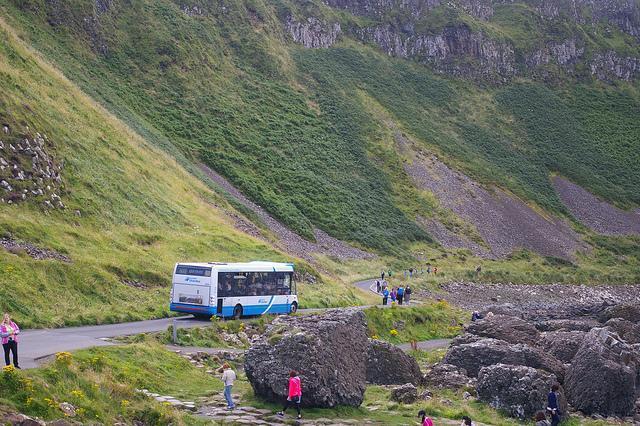How many big orange are there in the image ?
Give a very brief answer. 0. 